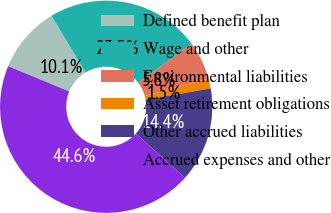Convert chart to OTSL. <chart><loc_0><loc_0><loc_500><loc_500><pie_chart><fcel>Defined benefit plan<fcel>Wage and other<fcel>Environmental liabilities<fcel>Asset retirement obligations<fcel>Other accrued liabilities<fcel>Accrued expenses and other<nl><fcel>10.14%<fcel>23.49%<fcel>5.83%<fcel>1.53%<fcel>14.44%<fcel>44.57%<nl></chart> 